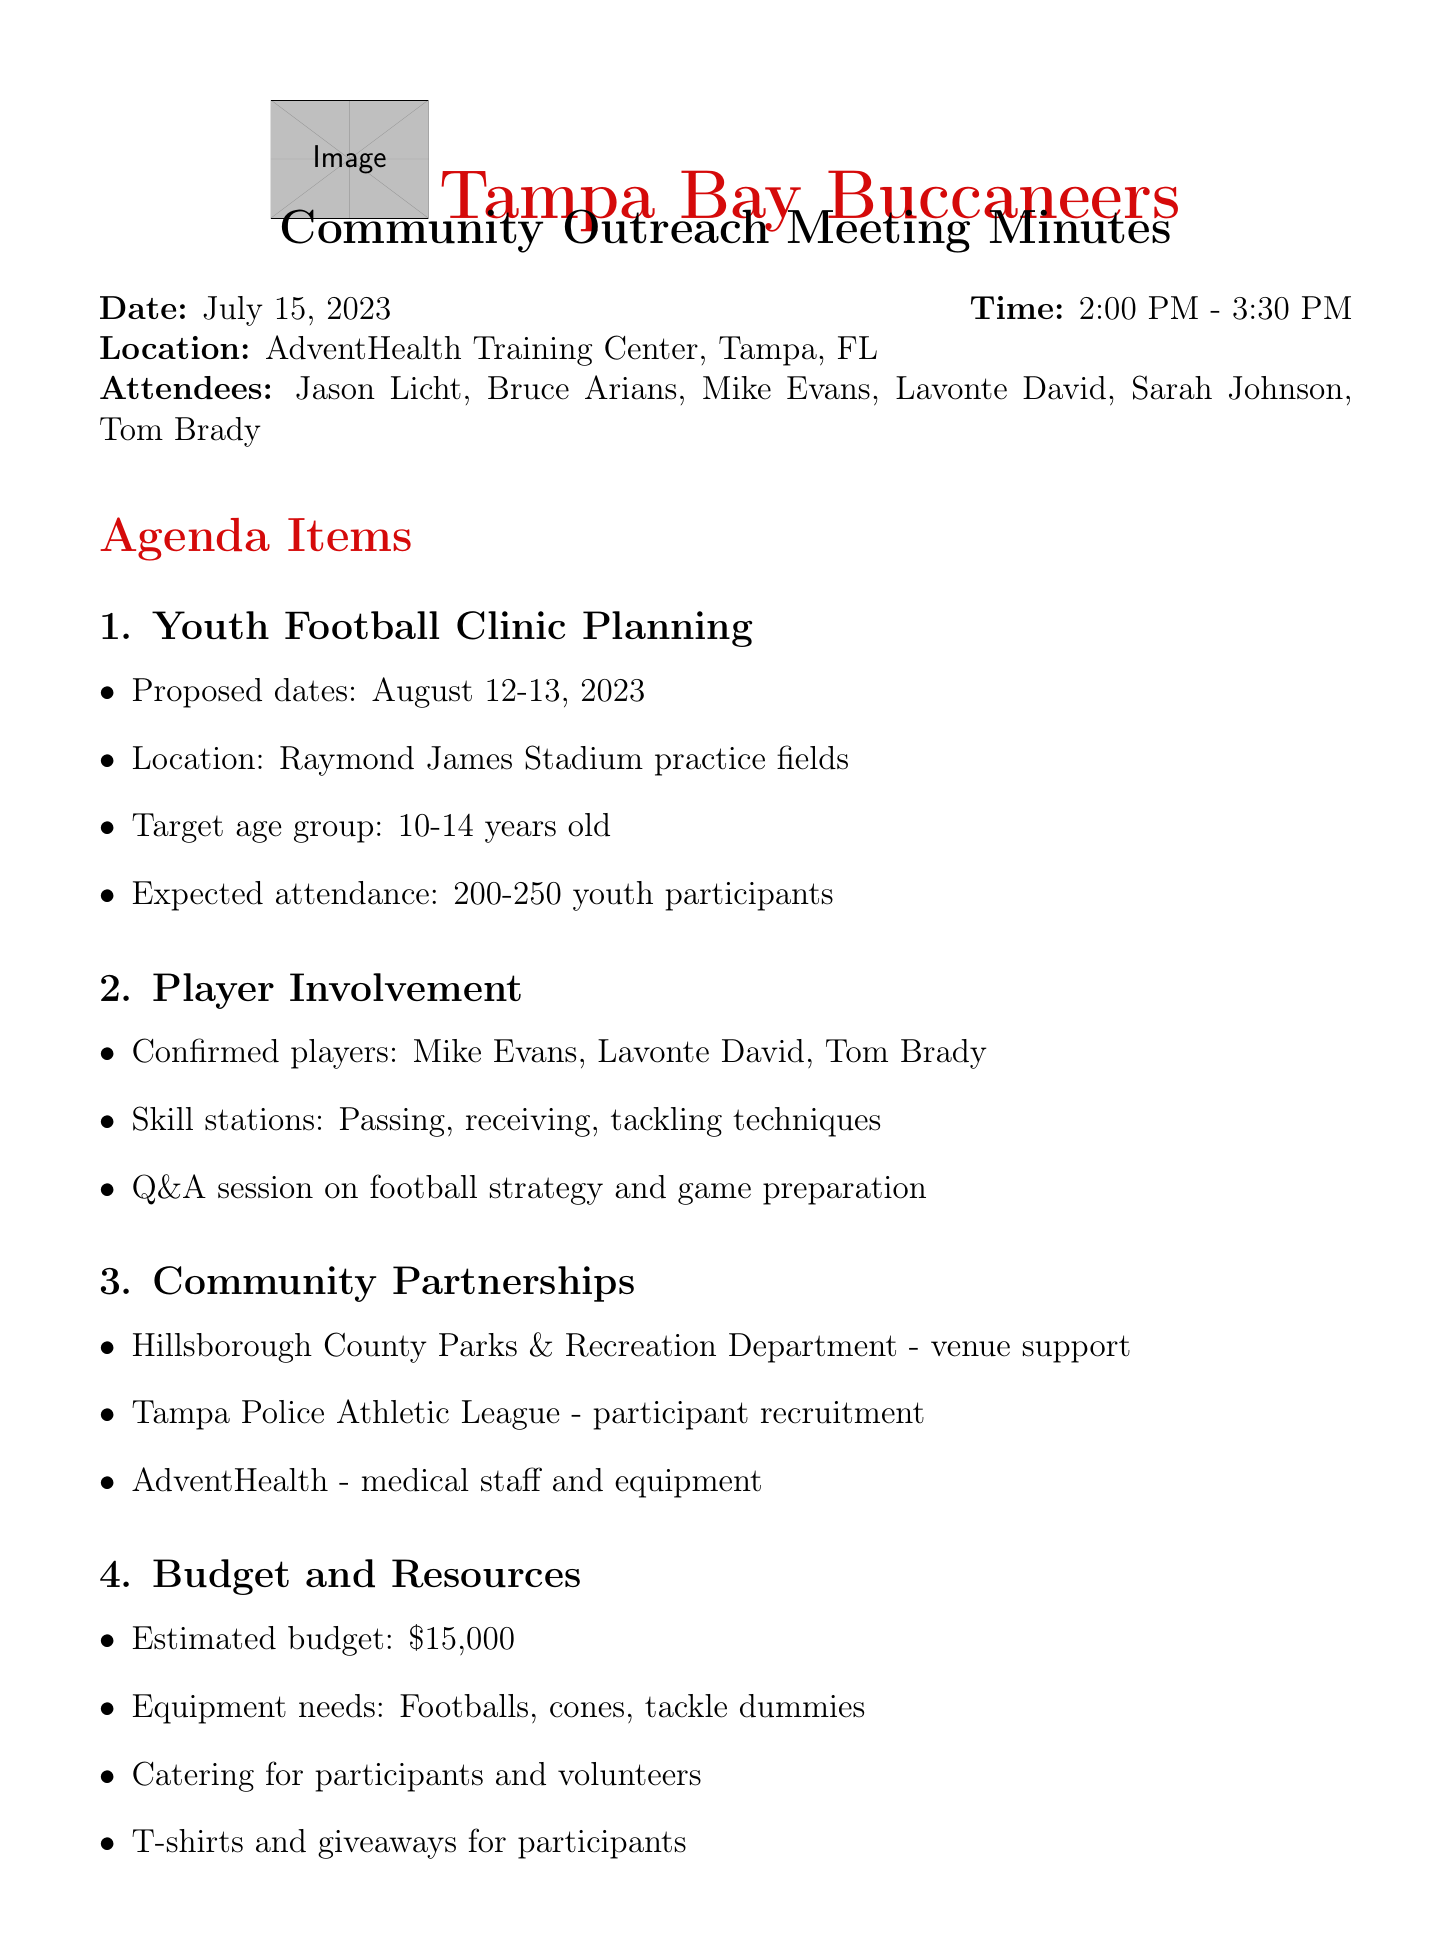What is the date of the meeting? The date of the meeting is clearly stated in the document.
Answer: July 15, 2023 What time did the meeting start? The starting time of the meeting is mentioned in the meeting details.
Answer: 2:00 PM Who are the confirmed players involved in the clinic? This information can be found under the player involvement section of the meeting minutes.
Answer: Mike Evans, Lavonte David, Tom Brady What is the estimated budget for the clinic? The estimated budget is explicitly listed in the budget and resources section.
Answer: $15,000 What are the proposed dates for the youth football clinic? The proposed dates are discussed in the youth football clinic planning section of the agenda.
Answer: August 12-13, 2023 How many youth participants are expected to attend? The expected attendance is specified in the agenda item regarding youth football clinic planning.
Answer: 200-250 Who is responsible for securing the venue permit and insurance? This action item is clearly assigned to an attendee in the action items section.
Answer: Sarah Johnson What social media campaign will be used for promotion? The marketing and promotion section states the hashtag for the campaign.
Answer: #BucsYouthClinic What location will the clinic take place? The location is mentioned in the youth football clinic planning agenda item.
Answer: Raymond James Stadium practice fields 